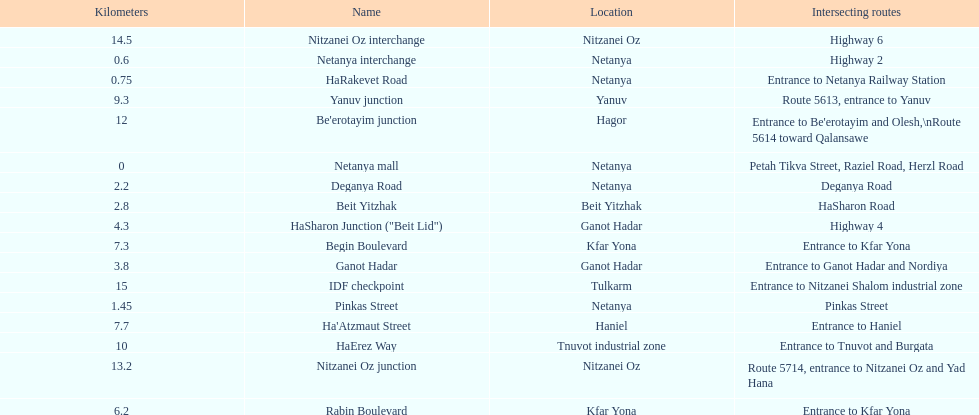Which section is longest?? IDF checkpoint. 